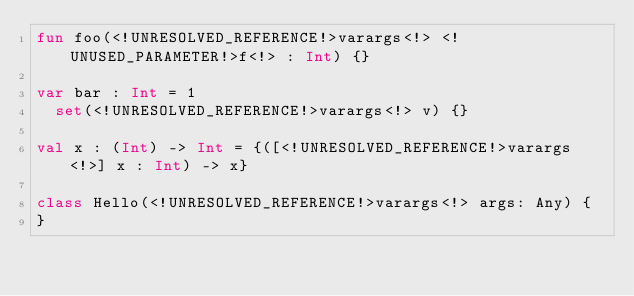<code> <loc_0><loc_0><loc_500><loc_500><_Kotlin_>fun foo(<!UNRESOLVED_REFERENCE!>varargs<!> <!UNUSED_PARAMETER!>f<!> : Int) {}

var bar : Int = 1
  set(<!UNRESOLVED_REFERENCE!>varargs<!> v) {}

val x : (Int) -> Int = {([<!UNRESOLVED_REFERENCE!>varargs<!>] x : Int) -> x}

class Hello(<!UNRESOLVED_REFERENCE!>varargs<!> args: Any) {
}</code> 